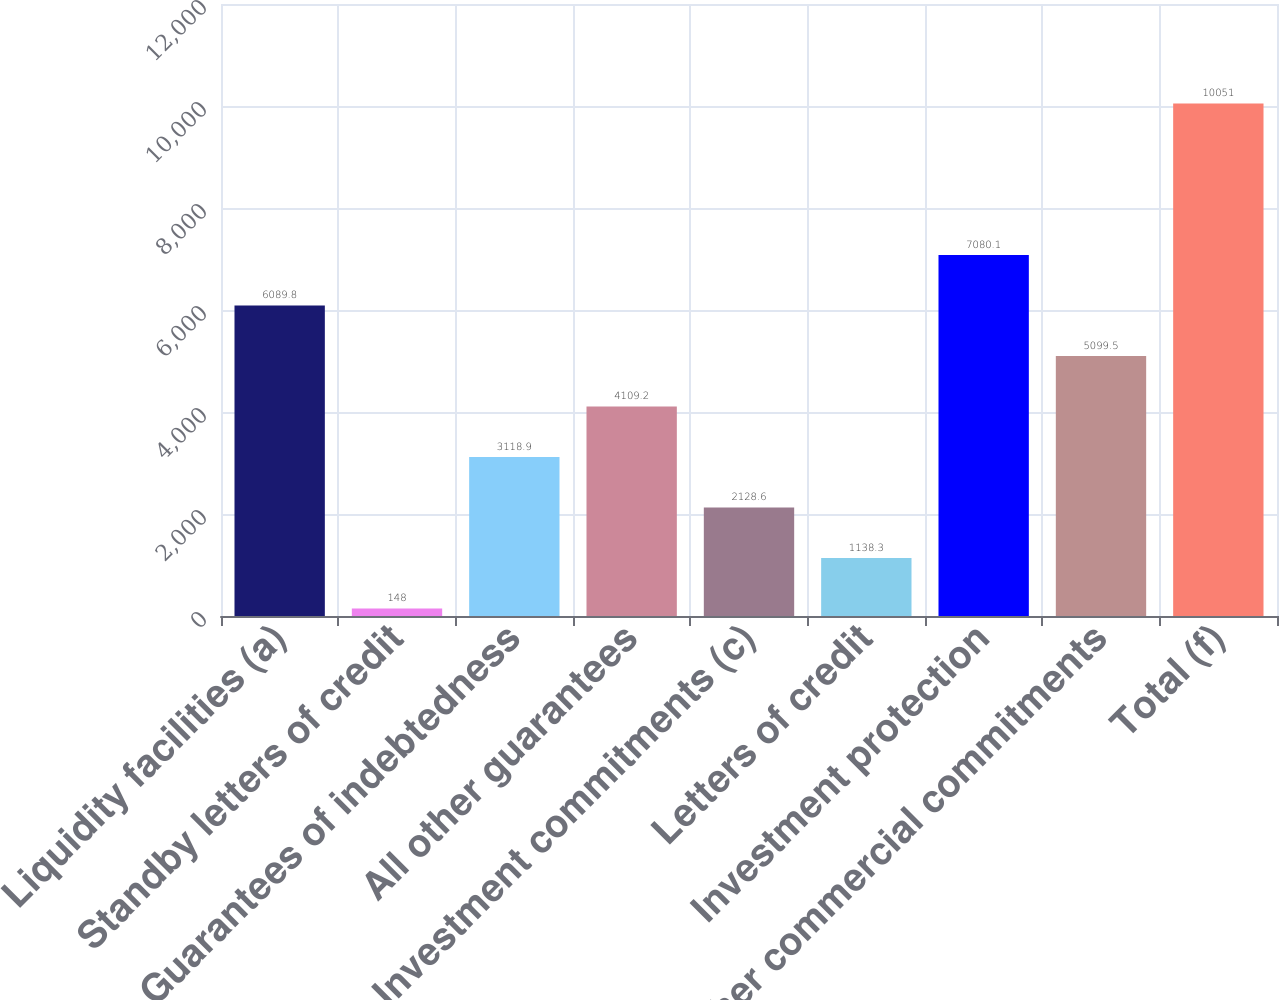Convert chart. <chart><loc_0><loc_0><loc_500><loc_500><bar_chart><fcel>Liquidity facilities (a)<fcel>Standby letters of credit<fcel>Guarantees of indebtedness<fcel>All other guarantees<fcel>Investment commitments (c)<fcel>Letters of credit<fcel>Investment protection<fcel>Other commercial commitments<fcel>Total (f)<nl><fcel>6089.8<fcel>148<fcel>3118.9<fcel>4109.2<fcel>2128.6<fcel>1138.3<fcel>7080.1<fcel>5099.5<fcel>10051<nl></chart> 